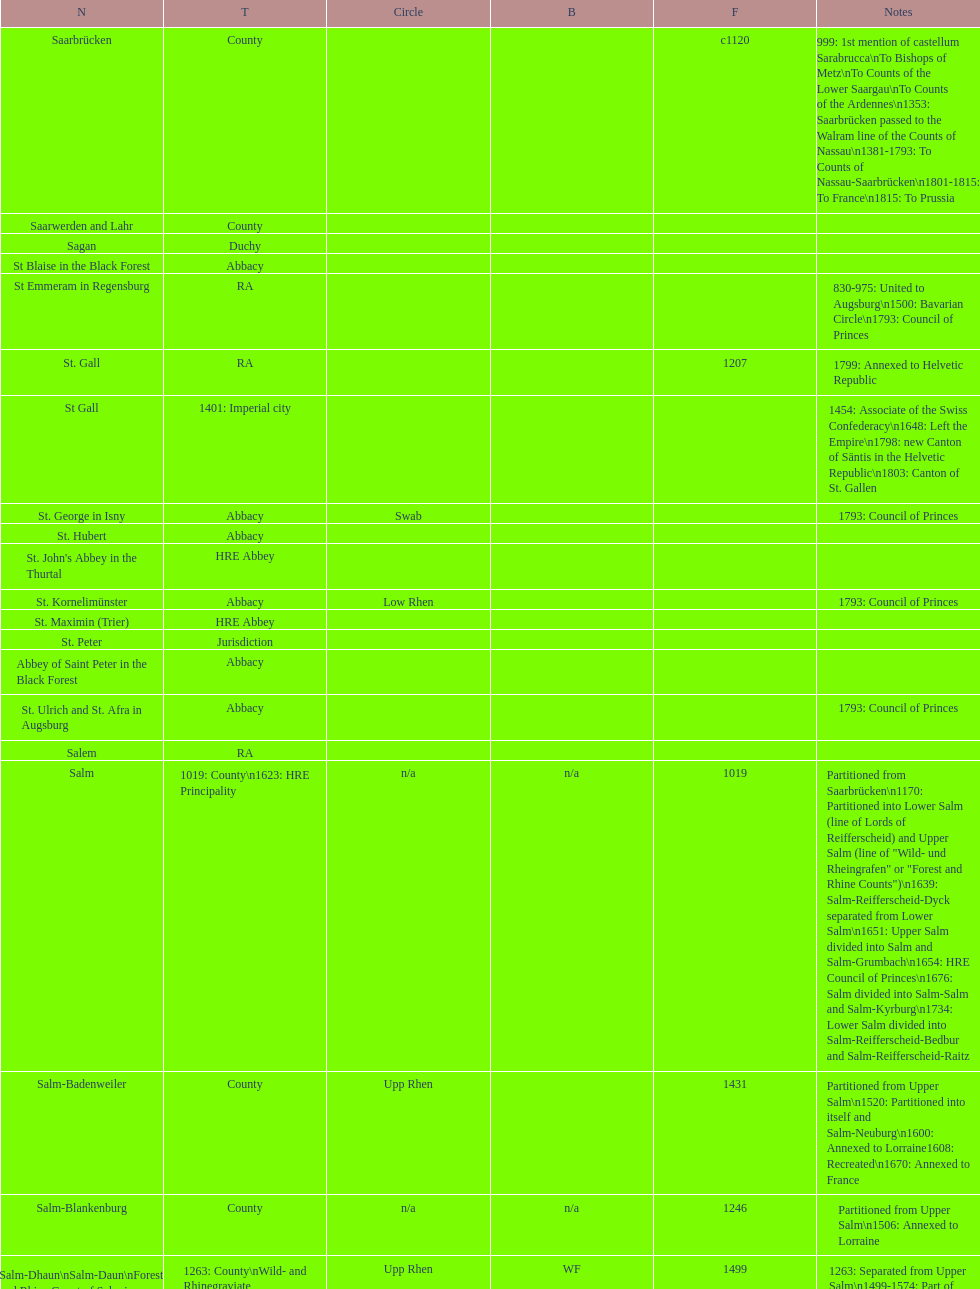Which bench is represented the most? PR. 